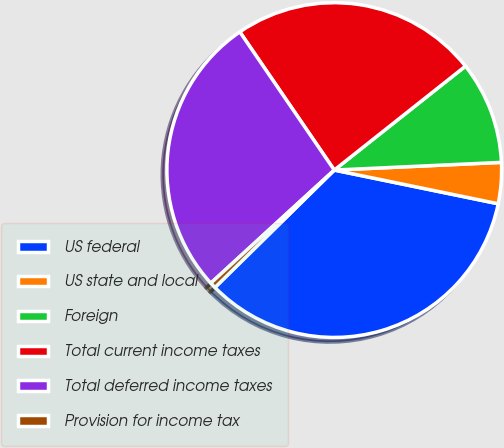Convert chart. <chart><loc_0><loc_0><loc_500><loc_500><pie_chart><fcel>US federal<fcel>US state and local<fcel>Foreign<fcel>Total current income taxes<fcel>Total deferred income taxes<fcel>Provision for income tax<nl><fcel>34.4%<fcel>3.96%<fcel>9.93%<fcel>23.88%<fcel>27.26%<fcel>0.57%<nl></chart> 